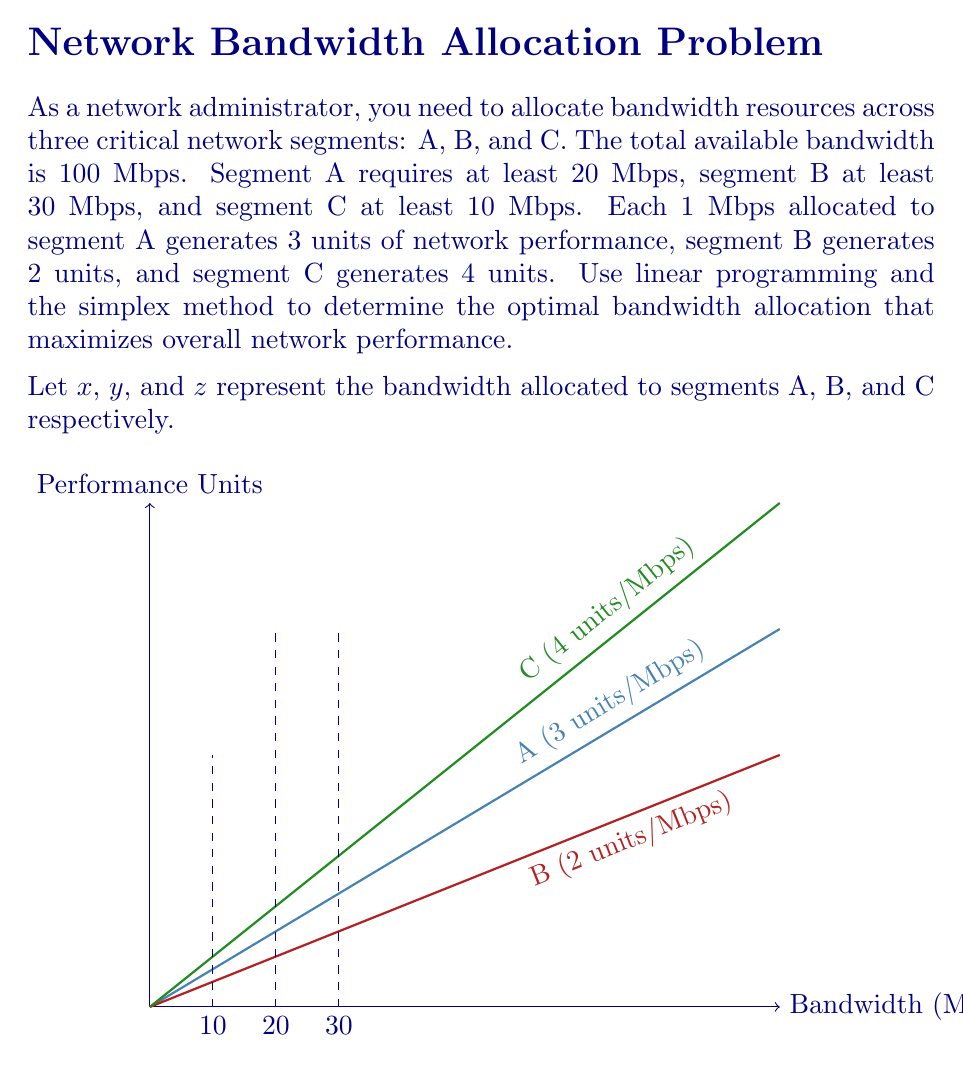Provide a solution to this math problem. To solve this problem using linear programming and the simplex method, we'll follow these steps:

1) Formulate the linear programming problem:

   Maximize: $Z = 3x + 2y + 4z$ (objective function)
   Subject to:
   $x + y + z \leq 100$ (total bandwidth constraint)
   $x \geq 20$ (minimum for A)
   $y \geq 30$ (minimum for B)
   $z \geq 10$ (minimum for C)
   $x, y, z \geq 0$ (non-negativity constraints)

2) Convert to standard form by introducing slack variables:

   Maximize: $Z = 3x + 2y + 4z + 0s_1 + 0s_2 + 0s_3 + 0s_4$
   Subject to:
   $x + y + z + s_1 = 100$
   $x - s_2 = 20$
   $y - s_3 = 30$
   $z - s_4 = 10$
   $x, y, z, s_1, s_2, s_3, s_4 \geq 0$

3) Set up the initial simplex tableau:

   $$\begin{array}{c|cccccccc|c}
     & x & y & z & s_1 & s_2 & s_3 & s_4 & Z & RHS \\
   \hline
   s_1 & 1 & 1 & 1 & 1 & 0 & 0 & 0 & 0 & 100 \\
   x & 1 & 0 & 0 & 0 & -1 & 0 & 0 & 0 & 20 \\
   y & 0 & 1 & 0 & 0 & 0 & -1 & 0 & 0 & 30 \\
   z & 0 & 0 & 1 & 0 & 0 & 0 & -1 & 0 & 10 \\
   \hline
   Z & -3 & -2 & -4 & 0 & 0 & 0 & 0 & 1 & 0
   \end{array}$$

4) Apply the simplex method:
   - The most negative entry in the Z row is -4, corresponding to z.
   - The pivot column is the z column.
   - The smallest ratio of RHS to pivot column is 10/1 = 10, corresponding to the z row.
   - Perform row operations to make the pivot element 1 and other entries in the column 0.

5) After several iterations, we reach the optimal solution:

   $$\begin{array}{c|cccccccc|c}
     & x & y & z & s_1 & s_2 & s_3 & s_4 & Z & RHS \\
   \hline
   z & 0 & 0 & 1 & 1 & 0 & 0 & 0 & 0 & 40 \\
   x & 1 & 0 & 0 & 0 & 1 & 0 & 0 & 0 & 20 \\
   y & 0 & 1 & 0 & 0 & 0 & 1 & 0 & 0 & 30 \\
   s_4 & 0 & 0 & 0 & -1 & 0 & 0 & 1 & 0 & 30 \\
   \hline
   Z & 0 & 0 & 0 & 4 & 3 & 2 & 4 & 1 & 280
   \end{array}$$

6) The optimal solution is:
   $x = 20$ Mbps (Segment A)
   $y = 30$ Mbps (Segment B)
   $z = 40$ Mbps (Segment C)
   $s_1 = 10$ Mbps (unused bandwidth)

The maximum network performance is 280 units.
Answer: Optimal allocation: A: 20 Mbps, B: 30 Mbps, C: 40 Mbps. Max performance: 280 units. 